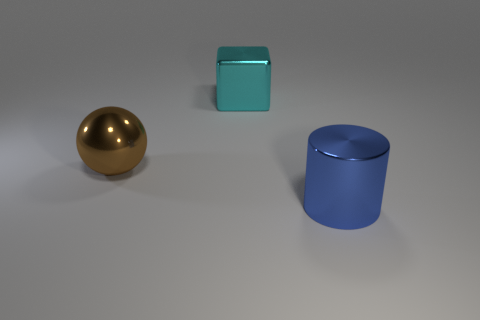There is a metallic object left of the metal object that is behind the large metallic ball in front of the large cyan metal cube; what shape is it?
Provide a short and direct response. Sphere. What shape is the brown object that is the same size as the cylinder?
Ensure brevity in your answer.  Sphere. There is a big object in front of the large metal object that is left of the big cyan shiny block; what number of cyan metal things are left of it?
Ensure brevity in your answer.  1. Is the number of brown things that are to the left of the blue metallic thing greater than the number of large things left of the big brown shiny ball?
Provide a succinct answer. Yes. What number of objects are big things behind the large shiny cylinder or objects that are in front of the cyan metal object?
Your response must be concise. 3. There is a large thing right of the shiny object behind the big shiny object left of the big metallic cube; what is it made of?
Offer a very short reply. Metal. Is there a blue shiny object of the same size as the shiny sphere?
Your answer should be very brief. Yes. What number of big green matte things are there?
Provide a short and direct response. 0. There is a large brown ball; how many big metal cylinders are right of it?
Your answer should be very brief. 1. What number of things are both right of the brown metal ball and to the left of the large cylinder?
Your answer should be compact. 1. 